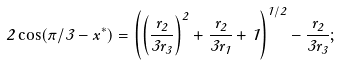<formula> <loc_0><loc_0><loc_500><loc_500>2 \cos ( \pi / 3 - x ^ { * } ) = { \left ( { \left ( \frac { r _ { 2 } } { 3 r _ { 3 } } \right ) } ^ { 2 } + \frac { r _ { 2 } } { 3 r _ { 1 } } + 1 \right ) } ^ { 1 / 2 } - \frac { r _ { 2 } } { 3 r _ { 3 } } ;</formula> 